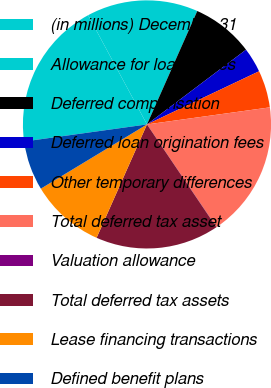Convert chart. <chart><loc_0><loc_0><loc_500><loc_500><pie_chart><fcel>(in millions) December 31<fcel>Allowance for loan losses<fcel>Deferred compensation<fcel>Deferred loan origination fees<fcel>Other temporary differences<fcel>Total deferred tax asset<fcel>Valuation allowance<fcel>Total deferred tax assets<fcel>Lease financing transactions<fcel>Defined benefit plans<nl><fcel>19.33%<fcel>14.51%<fcel>8.07%<fcel>3.24%<fcel>4.85%<fcel>17.72%<fcel>0.02%<fcel>16.11%<fcel>9.68%<fcel>6.46%<nl></chart> 